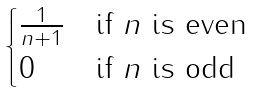<formula> <loc_0><loc_0><loc_500><loc_500>\begin{cases} \frac { 1 } { n + 1 } & \text {if } n \text { is even} \\ 0 & \text {if } n \text { is odd} \end{cases}</formula> 